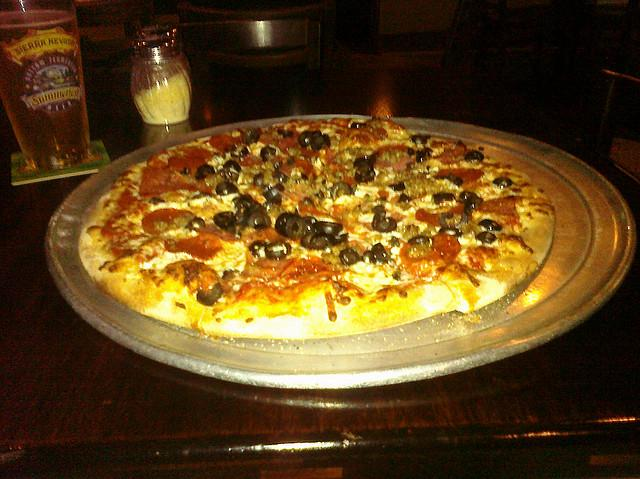What is in the shaker jar next to the beverage? parmesan cheese 